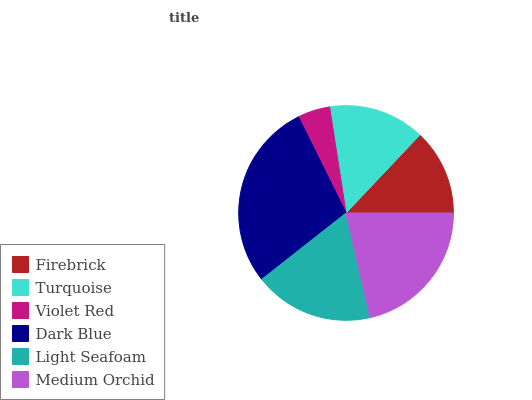Is Violet Red the minimum?
Answer yes or no. Yes. Is Dark Blue the maximum?
Answer yes or no. Yes. Is Turquoise the minimum?
Answer yes or no. No. Is Turquoise the maximum?
Answer yes or no. No. Is Turquoise greater than Firebrick?
Answer yes or no. Yes. Is Firebrick less than Turquoise?
Answer yes or no. Yes. Is Firebrick greater than Turquoise?
Answer yes or no. No. Is Turquoise less than Firebrick?
Answer yes or no. No. Is Light Seafoam the high median?
Answer yes or no. Yes. Is Turquoise the low median?
Answer yes or no. Yes. Is Violet Red the high median?
Answer yes or no. No. Is Firebrick the low median?
Answer yes or no. No. 